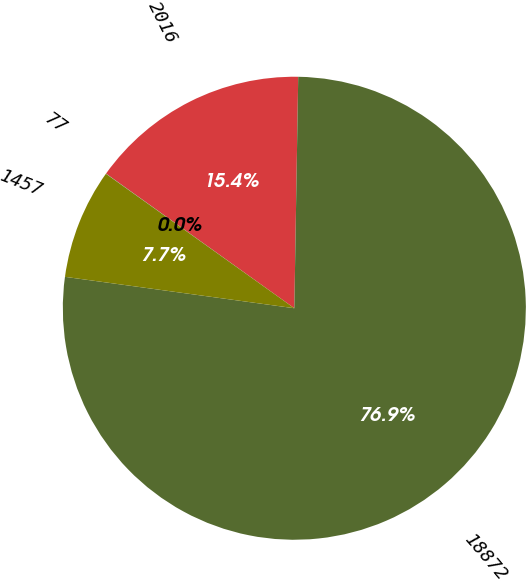Convert chart. <chart><loc_0><loc_0><loc_500><loc_500><pie_chart><fcel>2016<fcel>18872<fcel>1457<fcel>77<nl><fcel>15.39%<fcel>76.9%<fcel>7.7%<fcel>0.01%<nl></chart> 